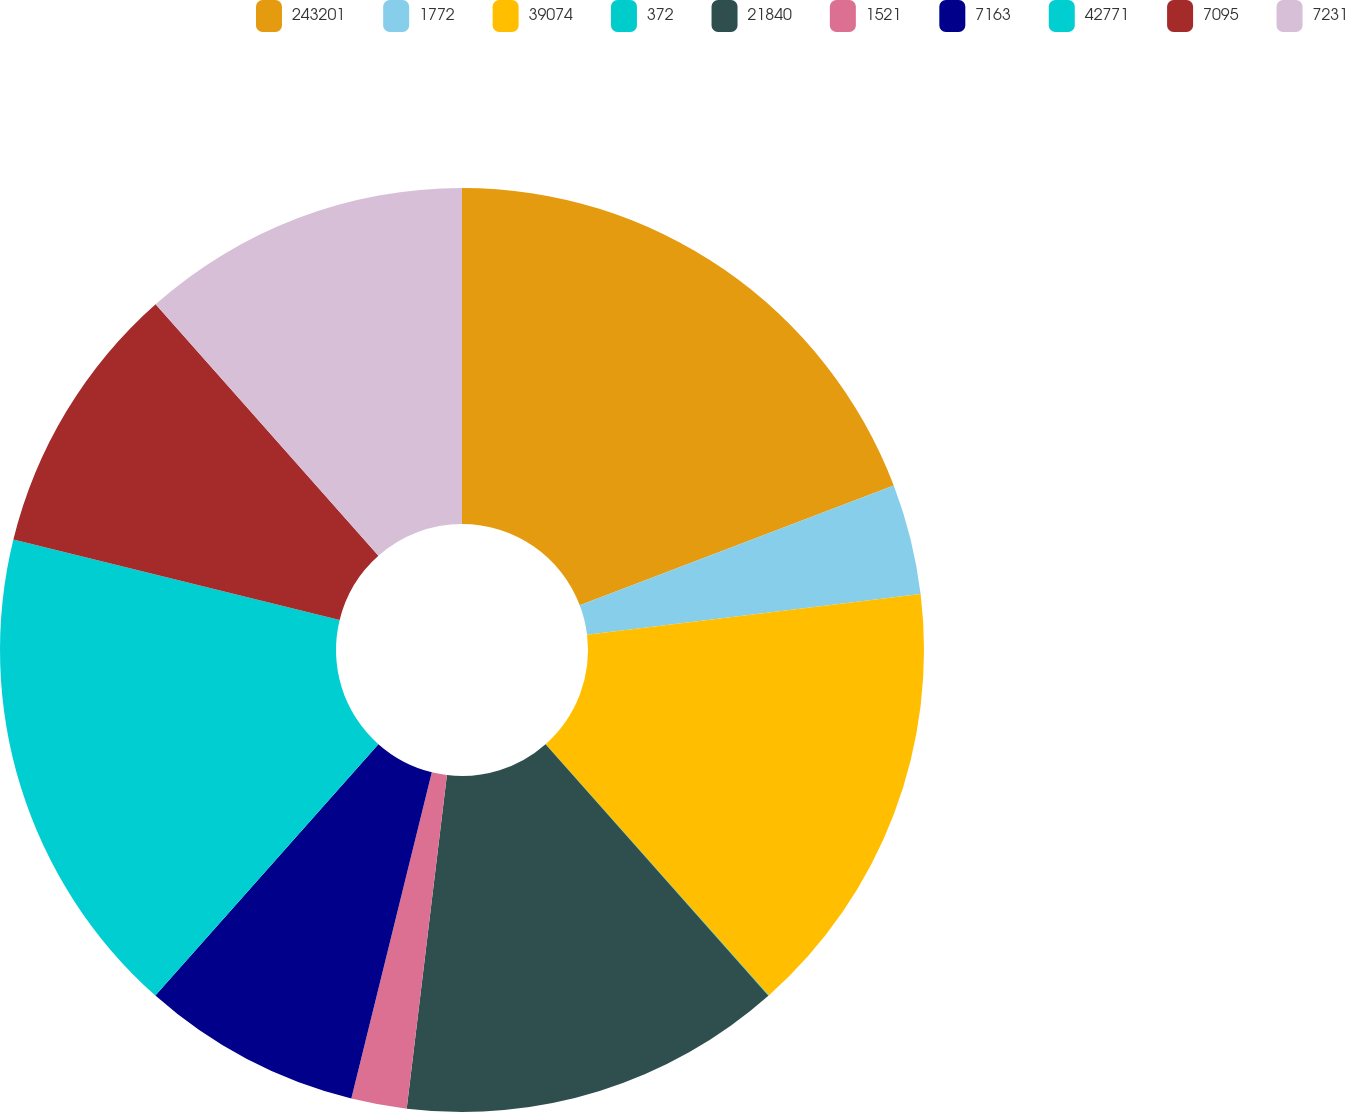Convert chart. <chart><loc_0><loc_0><loc_500><loc_500><pie_chart><fcel>243201<fcel>1772<fcel>39074<fcel>372<fcel>21840<fcel>1521<fcel>7163<fcel>42771<fcel>7095<fcel>7231<nl><fcel>19.21%<fcel>3.86%<fcel>15.37%<fcel>0.02%<fcel>13.45%<fcel>1.94%<fcel>7.7%<fcel>17.29%<fcel>9.62%<fcel>11.54%<nl></chart> 